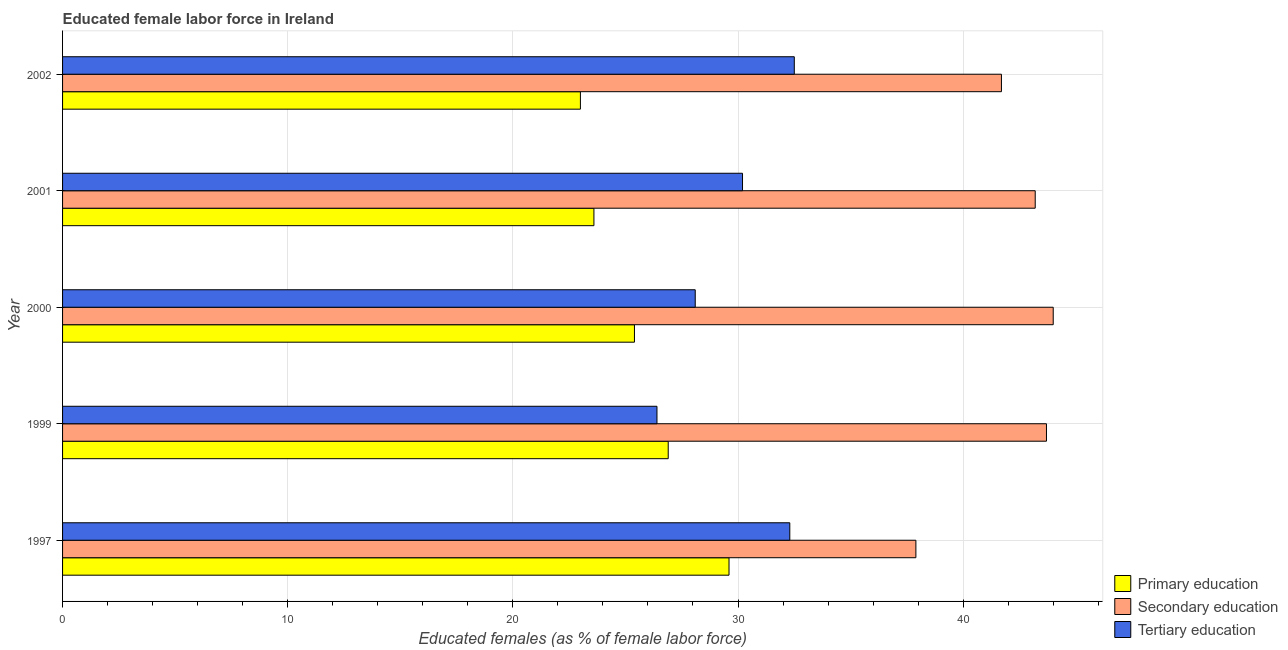How many groups of bars are there?
Ensure brevity in your answer.  5. Are the number of bars per tick equal to the number of legend labels?
Keep it short and to the point. Yes. Are the number of bars on each tick of the Y-axis equal?
Your answer should be compact. Yes. How many bars are there on the 4th tick from the top?
Your answer should be compact. 3. In how many cases, is the number of bars for a given year not equal to the number of legend labels?
Offer a very short reply. 0. Across all years, what is the minimum percentage of female labor force who received tertiary education?
Make the answer very short. 26.4. What is the total percentage of female labor force who received primary education in the graph?
Ensure brevity in your answer.  128.5. What is the average percentage of female labor force who received secondary education per year?
Ensure brevity in your answer.  42.1. In how many years, is the percentage of female labor force who received secondary education greater than 24 %?
Keep it short and to the point. 5. Is the difference between the percentage of female labor force who received tertiary education in 1997 and 2000 greater than the difference between the percentage of female labor force who received primary education in 1997 and 2000?
Your answer should be compact. No. In how many years, is the percentage of female labor force who received tertiary education greater than the average percentage of female labor force who received tertiary education taken over all years?
Provide a short and direct response. 3. Is the sum of the percentage of female labor force who received primary education in 1999 and 2001 greater than the maximum percentage of female labor force who received tertiary education across all years?
Give a very brief answer. Yes. What does the 2nd bar from the top in 2000 represents?
Give a very brief answer. Secondary education. What does the 3rd bar from the bottom in 2001 represents?
Offer a terse response. Tertiary education. Is it the case that in every year, the sum of the percentage of female labor force who received primary education and percentage of female labor force who received secondary education is greater than the percentage of female labor force who received tertiary education?
Offer a very short reply. Yes. Are all the bars in the graph horizontal?
Your response must be concise. Yes. Does the graph contain any zero values?
Provide a short and direct response. No. Where does the legend appear in the graph?
Provide a short and direct response. Bottom right. What is the title of the graph?
Provide a short and direct response. Educated female labor force in Ireland. What is the label or title of the X-axis?
Your answer should be compact. Educated females (as % of female labor force). What is the Educated females (as % of female labor force) in Primary education in 1997?
Offer a very short reply. 29.6. What is the Educated females (as % of female labor force) in Secondary education in 1997?
Give a very brief answer. 37.9. What is the Educated females (as % of female labor force) of Tertiary education in 1997?
Your response must be concise. 32.3. What is the Educated females (as % of female labor force) of Primary education in 1999?
Offer a very short reply. 26.9. What is the Educated females (as % of female labor force) in Secondary education in 1999?
Provide a short and direct response. 43.7. What is the Educated females (as % of female labor force) of Tertiary education in 1999?
Provide a succinct answer. 26.4. What is the Educated females (as % of female labor force) in Primary education in 2000?
Give a very brief answer. 25.4. What is the Educated females (as % of female labor force) in Tertiary education in 2000?
Make the answer very short. 28.1. What is the Educated females (as % of female labor force) of Primary education in 2001?
Make the answer very short. 23.6. What is the Educated females (as % of female labor force) in Secondary education in 2001?
Make the answer very short. 43.2. What is the Educated females (as % of female labor force) of Tertiary education in 2001?
Provide a short and direct response. 30.2. What is the Educated females (as % of female labor force) of Primary education in 2002?
Ensure brevity in your answer.  23. What is the Educated females (as % of female labor force) of Secondary education in 2002?
Keep it short and to the point. 41.7. What is the Educated females (as % of female labor force) of Tertiary education in 2002?
Your answer should be compact. 32.5. Across all years, what is the maximum Educated females (as % of female labor force) of Primary education?
Your answer should be compact. 29.6. Across all years, what is the maximum Educated females (as % of female labor force) in Secondary education?
Provide a short and direct response. 44. Across all years, what is the maximum Educated females (as % of female labor force) in Tertiary education?
Offer a terse response. 32.5. Across all years, what is the minimum Educated females (as % of female labor force) of Secondary education?
Provide a succinct answer. 37.9. Across all years, what is the minimum Educated females (as % of female labor force) of Tertiary education?
Keep it short and to the point. 26.4. What is the total Educated females (as % of female labor force) in Primary education in the graph?
Your response must be concise. 128.5. What is the total Educated females (as % of female labor force) in Secondary education in the graph?
Offer a terse response. 210.5. What is the total Educated females (as % of female labor force) in Tertiary education in the graph?
Offer a terse response. 149.5. What is the difference between the Educated females (as % of female labor force) in Primary education in 1997 and that in 1999?
Offer a very short reply. 2.7. What is the difference between the Educated females (as % of female labor force) of Secondary education in 1997 and that in 1999?
Provide a short and direct response. -5.8. What is the difference between the Educated females (as % of female labor force) in Tertiary education in 1997 and that in 1999?
Your response must be concise. 5.9. What is the difference between the Educated females (as % of female labor force) in Secondary education in 1997 and that in 2000?
Give a very brief answer. -6.1. What is the difference between the Educated females (as % of female labor force) in Primary education in 1997 and that in 2001?
Provide a short and direct response. 6. What is the difference between the Educated females (as % of female labor force) in Primary education in 1997 and that in 2002?
Offer a very short reply. 6.6. What is the difference between the Educated females (as % of female labor force) of Secondary education in 1997 and that in 2002?
Make the answer very short. -3.8. What is the difference between the Educated females (as % of female labor force) of Primary education in 1999 and that in 2000?
Give a very brief answer. 1.5. What is the difference between the Educated females (as % of female labor force) of Primary education in 1999 and that in 2001?
Your answer should be very brief. 3.3. What is the difference between the Educated females (as % of female labor force) of Secondary education in 1999 and that in 2001?
Keep it short and to the point. 0.5. What is the difference between the Educated females (as % of female labor force) of Secondary education in 1999 and that in 2002?
Your response must be concise. 2. What is the difference between the Educated females (as % of female labor force) in Primary education in 2000 and that in 2001?
Make the answer very short. 1.8. What is the difference between the Educated females (as % of female labor force) in Tertiary education in 2000 and that in 2001?
Your answer should be very brief. -2.1. What is the difference between the Educated females (as % of female labor force) in Tertiary education in 2001 and that in 2002?
Offer a terse response. -2.3. What is the difference between the Educated females (as % of female labor force) in Primary education in 1997 and the Educated females (as % of female labor force) in Secondary education in 1999?
Your response must be concise. -14.1. What is the difference between the Educated females (as % of female labor force) in Secondary education in 1997 and the Educated females (as % of female labor force) in Tertiary education in 1999?
Provide a short and direct response. 11.5. What is the difference between the Educated females (as % of female labor force) in Primary education in 1997 and the Educated females (as % of female labor force) in Secondary education in 2000?
Offer a very short reply. -14.4. What is the difference between the Educated females (as % of female labor force) of Primary education in 1997 and the Educated females (as % of female labor force) of Tertiary education in 2000?
Give a very brief answer. 1.5. What is the difference between the Educated females (as % of female labor force) in Primary education in 1997 and the Educated females (as % of female labor force) in Tertiary education in 2002?
Give a very brief answer. -2.9. What is the difference between the Educated females (as % of female labor force) of Secondary education in 1997 and the Educated females (as % of female labor force) of Tertiary education in 2002?
Ensure brevity in your answer.  5.4. What is the difference between the Educated females (as % of female labor force) in Primary education in 1999 and the Educated females (as % of female labor force) in Secondary education in 2000?
Offer a very short reply. -17.1. What is the difference between the Educated females (as % of female labor force) in Primary education in 1999 and the Educated females (as % of female labor force) in Tertiary education in 2000?
Offer a very short reply. -1.2. What is the difference between the Educated females (as % of female labor force) of Primary education in 1999 and the Educated females (as % of female labor force) of Secondary education in 2001?
Keep it short and to the point. -16.3. What is the difference between the Educated females (as % of female labor force) of Primary education in 1999 and the Educated females (as % of female labor force) of Secondary education in 2002?
Your answer should be compact. -14.8. What is the difference between the Educated females (as % of female labor force) of Primary education in 1999 and the Educated females (as % of female labor force) of Tertiary education in 2002?
Ensure brevity in your answer.  -5.6. What is the difference between the Educated females (as % of female labor force) of Primary education in 2000 and the Educated females (as % of female labor force) of Secondary education in 2001?
Your answer should be very brief. -17.8. What is the difference between the Educated females (as % of female labor force) of Secondary education in 2000 and the Educated females (as % of female labor force) of Tertiary education in 2001?
Provide a succinct answer. 13.8. What is the difference between the Educated females (as % of female labor force) in Primary education in 2000 and the Educated females (as % of female labor force) in Secondary education in 2002?
Provide a short and direct response. -16.3. What is the difference between the Educated females (as % of female labor force) in Primary education in 2001 and the Educated females (as % of female labor force) in Secondary education in 2002?
Your answer should be very brief. -18.1. What is the difference between the Educated females (as % of female labor force) in Primary education in 2001 and the Educated females (as % of female labor force) in Tertiary education in 2002?
Offer a very short reply. -8.9. What is the difference between the Educated females (as % of female labor force) of Secondary education in 2001 and the Educated females (as % of female labor force) of Tertiary education in 2002?
Your answer should be compact. 10.7. What is the average Educated females (as % of female labor force) of Primary education per year?
Give a very brief answer. 25.7. What is the average Educated females (as % of female labor force) in Secondary education per year?
Your answer should be compact. 42.1. What is the average Educated females (as % of female labor force) of Tertiary education per year?
Provide a short and direct response. 29.9. In the year 1997, what is the difference between the Educated females (as % of female labor force) in Primary education and Educated females (as % of female labor force) in Secondary education?
Your response must be concise. -8.3. In the year 1997, what is the difference between the Educated females (as % of female labor force) in Primary education and Educated females (as % of female labor force) in Tertiary education?
Your answer should be compact. -2.7. In the year 1999, what is the difference between the Educated females (as % of female labor force) in Primary education and Educated females (as % of female labor force) in Secondary education?
Provide a short and direct response. -16.8. In the year 2000, what is the difference between the Educated females (as % of female labor force) in Primary education and Educated females (as % of female labor force) in Secondary education?
Provide a succinct answer. -18.6. In the year 2000, what is the difference between the Educated females (as % of female labor force) in Primary education and Educated females (as % of female labor force) in Tertiary education?
Offer a terse response. -2.7. In the year 2001, what is the difference between the Educated females (as % of female labor force) in Primary education and Educated females (as % of female labor force) in Secondary education?
Offer a terse response. -19.6. In the year 2002, what is the difference between the Educated females (as % of female labor force) of Primary education and Educated females (as % of female labor force) of Secondary education?
Provide a succinct answer. -18.7. In the year 2002, what is the difference between the Educated females (as % of female labor force) in Primary education and Educated females (as % of female labor force) in Tertiary education?
Your answer should be compact. -9.5. In the year 2002, what is the difference between the Educated females (as % of female labor force) of Secondary education and Educated females (as % of female labor force) of Tertiary education?
Keep it short and to the point. 9.2. What is the ratio of the Educated females (as % of female labor force) of Primary education in 1997 to that in 1999?
Provide a succinct answer. 1.1. What is the ratio of the Educated females (as % of female labor force) in Secondary education in 1997 to that in 1999?
Provide a succinct answer. 0.87. What is the ratio of the Educated females (as % of female labor force) in Tertiary education in 1997 to that in 1999?
Your answer should be very brief. 1.22. What is the ratio of the Educated females (as % of female labor force) of Primary education in 1997 to that in 2000?
Provide a short and direct response. 1.17. What is the ratio of the Educated females (as % of female labor force) in Secondary education in 1997 to that in 2000?
Provide a short and direct response. 0.86. What is the ratio of the Educated females (as % of female labor force) in Tertiary education in 1997 to that in 2000?
Ensure brevity in your answer.  1.15. What is the ratio of the Educated females (as % of female labor force) of Primary education in 1997 to that in 2001?
Make the answer very short. 1.25. What is the ratio of the Educated females (as % of female labor force) of Secondary education in 1997 to that in 2001?
Your answer should be compact. 0.88. What is the ratio of the Educated females (as % of female labor force) of Tertiary education in 1997 to that in 2001?
Keep it short and to the point. 1.07. What is the ratio of the Educated females (as % of female labor force) of Primary education in 1997 to that in 2002?
Keep it short and to the point. 1.29. What is the ratio of the Educated females (as % of female labor force) of Secondary education in 1997 to that in 2002?
Your answer should be very brief. 0.91. What is the ratio of the Educated females (as % of female labor force) in Tertiary education in 1997 to that in 2002?
Your response must be concise. 0.99. What is the ratio of the Educated females (as % of female labor force) in Primary education in 1999 to that in 2000?
Your response must be concise. 1.06. What is the ratio of the Educated females (as % of female labor force) in Tertiary education in 1999 to that in 2000?
Give a very brief answer. 0.94. What is the ratio of the Educated females (as % of female labor force) in Primary education in 1999 to that in 2001?
Provide a succinct answer. 1.14. What is the ratio of the Educated females (as % of female labor force) of Secondary education in 1999 to that in 2001?
Your answer should be compact. 1.01. What is the ratio of the Educated females (as % of female labor force) of Tertiary education in 1999 to that in 2001?
Offer a terse response. 0.87. What is the ratio of the Educated females (as % of female labor force) of Primary education in 1999 to that in 2002?
Your answer should be very brief. 1.17. What is the ratio of the Educated females (as % of female labor force) of Secondary education in 1999 to that in 2002?
Keep it short and to the point. 1.05. What is the ratio of the Educated females (as % of female labor force) of Tertiary education in 1999 to that in 2002?
Your answer should be very brief. 0.81. What is the ratio of the Educated females (as % of female labor force) in Primary education in 2000 to that in 2001?
Provide a short and direct response. 1.08. What is the ratio of the Educated females (as % of female labor force) of Secondary education in 2000 to that in 2001?
Keep it short and to the point. 1.02. What is the ratio of the Educated females (as % of female labor force) of Tertiary education in 2000 to that in 2001?
Your answer should be very brief. 0.93. What is the ratio of the Educated females (as % of female labor force) in Primary education in 2000 to that in 2002?
Ensure brevity in your answer.  1.1. What is the ratio of the Educated females (as % of female labor force) of Secondary education in 2000 to that in 2002?
Give a very brief answer. 1.06. What is the ratio of the Educated females (as % of female labor force) in Tertiary education in 2000 to that in 2002?
Give a very brief answer. 0.86. What is the ratio of the Educated females (as % of female labor force) in Primary education in 2001 to that in 2002?
Offer a very short reply. 1.03. What is the ratio of the Educated females (as % of female labor force) of Secondary education in 2001 to that in 2002?
Your answer should be compact. 1.04. What is the ratio of the Educated females (as % of female labor force) in Tertiary education in 2001 to that in 2002?
Offer a very short reply. 0.93. What is the difference between the highest and the second highest Educated females (as % of female labor force) of Primary education?
Give a very brief answer. 2.7. What is the difference between the highest and the second highest Educated females (as % of female labor force) in Secondary education?
Your answer should be very brief. 0.3. What is the difference between the highest and the lowest Educated females (as % of female labor force) in Primary education?
Keep it short and to the point. 6.6. What is the difference between the highest and the lowest Educated females (as % of female labor force) of Secondary education?
Provide a succinct answer. 6.1. What is the difference between the highest and the lowest Educated females (as % of female labor force) of Tertiary education?
Give a very brief answer. 6.1. 